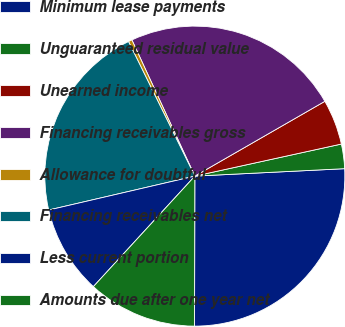Convert chart to OTSL. <chart><loc_0><loc_0><loc_500><loc_500><pie_chart><fcel>Minimum lease payments<fcel>Unguaranteed residual value<fcel>Unearned income<fcel>Financing receivables gross<fcel>Allowance for doubtful<fcel>Financing receivables net<fcel>Less current portion<fcel>Amounts due after one year net<nl><fcel>25.82%<fcel>2.64%<fcel>4.88%<fcel>23.58%<fcel>0.4%<fcel>21.34%<fcel>9.55%<fcel>11.79%<nl></chart> 